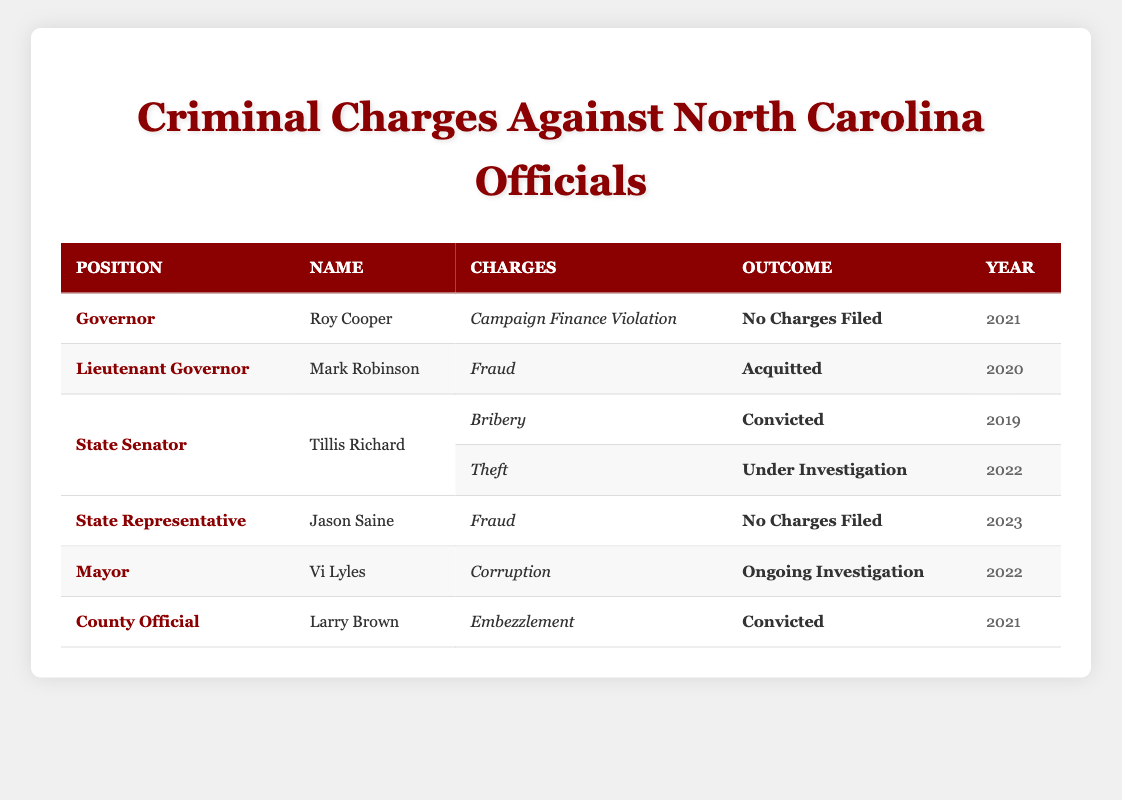What type of charge did Roy Cooper face? The table shows that Roy Cooper faced a charge of Campaign Finance Violation. This can be found directly under his name in the Charges column of the table.
Answer: Campaign Finance Violation How many officials have been convicted of charges? By examining the Outcome column in the table, we can see that there are two officials with the outcome "Convicted": Tillis Richard (Bribery) and Larry Brown (Embezzlement). Thus, the total is two.
Answer: 2 Did Mark Robinson face any charges that resulted in conviction? The table states that Mark Robinson was acquitted of the charge of Fraud, which means he did not face conviction. Therefore, the answer is no.
Answer: No Which official had charges still under investigation in 2022? Looking at the Year and Outcome columns, Vi Lyles is the official whose charge (Corruption) is listed as an ongoing investigation for the year 2022. This information clearly appears in the respective rows of the table.
Answer: Vi Lyles What is the difference between the outcomes of charges faced by State Senator Tillis Richard between 2019 and 2022? In 2019, Tillis Richard was convicted of bribery, while in 2022, he has a charge of theft that is under investigation. The difference in outcomes is between a conviction and an ongoing investigation.
Answer: Convicted vs. Under Investigation 